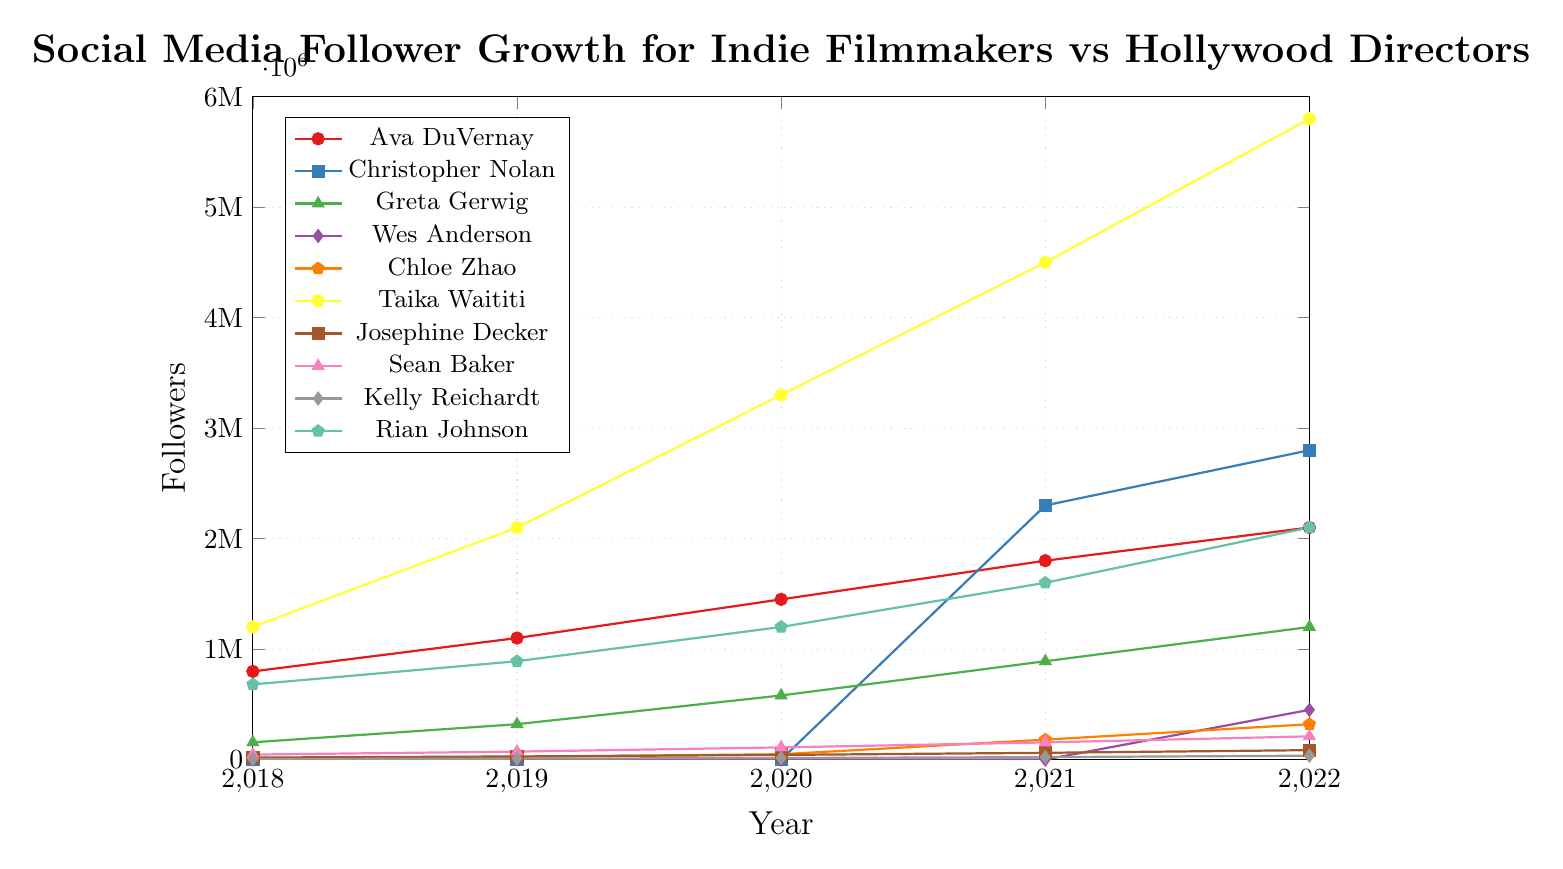How many followers did Taika Waititi gain between 2018 and 2022? In 2018, Taika Waititi had 1,200,000 followers, and this grew to 5,800,000 followers by 2022. The gain is calculated by subtracting the 2018 value from the 2022 value: 5,800,000 - 1,200,000.
Answer: 4,600,000 Which filmmaker had the highest number of followers in 2022? By examining the highest points on the y-axis corresponding to the year 2022, Taika Waititi is at the highest point with 5,800,000 followers.
Answer: Taika Waititi How did Ava DuVernay's follower growth compare to Sean Baker's follower growth in 2021? Ava DuVernay had 1,800,000 followers in 2021, while Sean Baker had 155,000. Ava DuVernay's followers were significantly higher.
Answer: Ava DuVernay had more What is the total number of followers for Kelly Reichardt over the years shown? Summing Kelly Reichardt's followers from 2018 to 2022: 5,000 + 8,000 + 14,000 + 22,000 + 35,000 = 84,000.
Answer: 84,000 Which year did Chloe Zhao see the largest increase in followers? The largest increase for Chloe Zhao can be calculated as follows: 
From 2018 to 2019: 25,000 - 12,000 = 13,000, 
from 2019 to 2020: 48,000 - 25,000 = 23,000, 
from 2020 to 2021: 180,000 - 48,000 = 132,000, 
from 2021 to 2022: 320,000 - 180,000 = 140,000. 
The largest increase was from 2020 to 2021.
Answer: 2021 Who had more followers in 2020, Christopher Nolan or Greta Gerwig? In 2020, Christopher Nolan had 0 followers (as indicated by the data), while Greta Gerwig had 580,000 followers.
Answer: Greta Gerwig What percentage of the followers Taika Waititi had in 2021 were gained by Chloe Zhao in 2022? Calculate Taika Waititi's followers in 2021: 4,500,000. Then calculate Chloe Zhao's followers in 2022: 320,000. The percentage is (320,000 / 4,500,000) * 100.
Answer: Approximately 7.11% By how much did the number of followers for Greta Gerwig increase from 2018 to 2022? Greta Gerwig's followers grew from 156,000 in 2018 to 1,200,000 in 2022. The increase is 1,200,000 - 156,000.
Answer: 1,044,000 